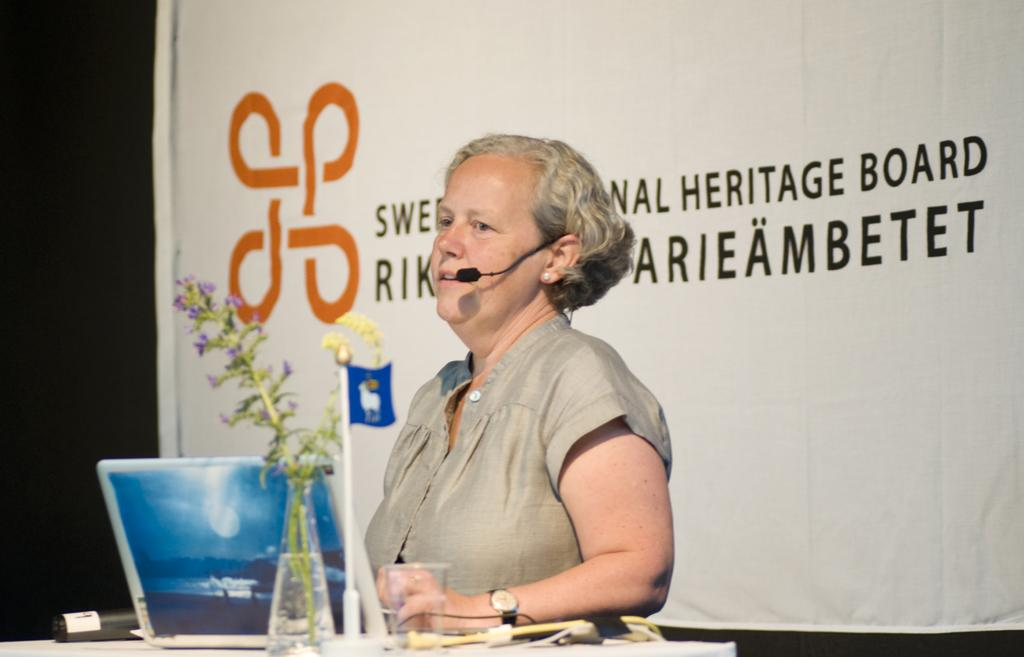Who is the main subject in the image? There is a lady in the image. What is the lady doing in the image? The lady is speaking into a microphone. What can be seen on the table in the image? There is a laptop on the table, as well as other objects. What is visible behind the lady in the image? There is a banner behind the lady. What information is provided on the banner? The banner has text written on it. What type of punishment is being administered to the lady in the image? There is no punishment being administered to the lady in the image; she is speaking into a microphone. Can you tell me where the map is located in the image? There is no map present in the image. 